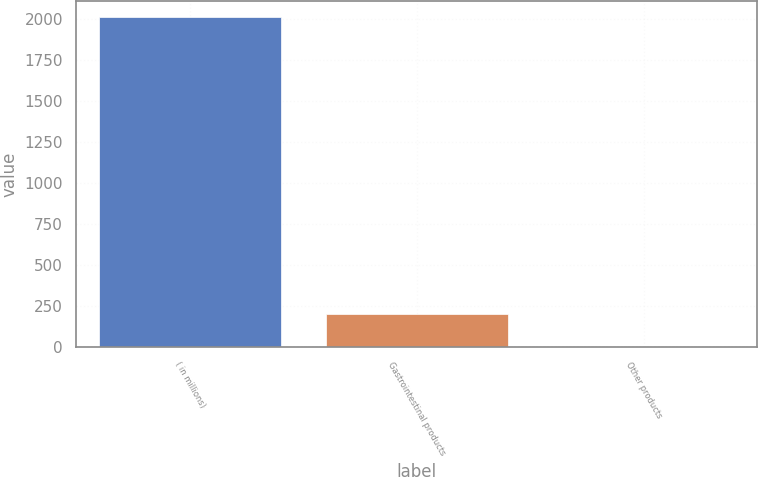Convert chart. <chart><loc_0><loc_0><loc_500><loc_500><bar_chart><fcel>( in millions)<fcel>Gastrointestinal products<fcel>Other products<nl><fcel>2009<fcel>202<fcel>1.2<nl></chart> 